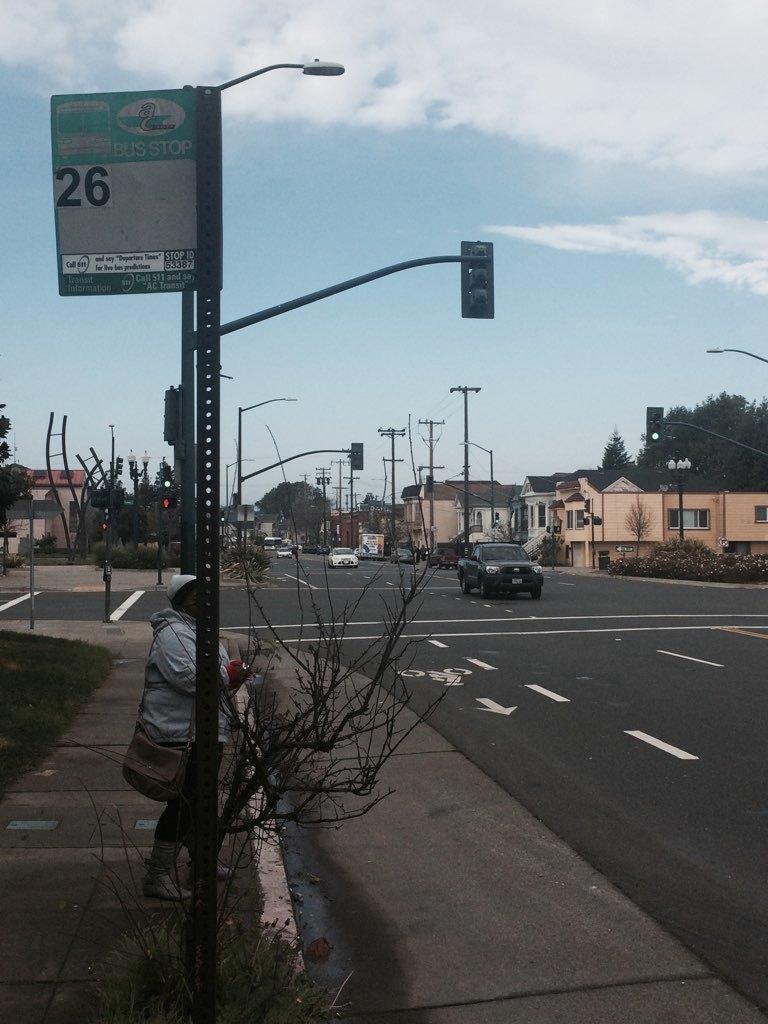Please provide a concise description of this image. At the bottom left of the image there is a footpath with a person is standing. And also there is a pole with posters, street light and traffic signal. At the bottom right corner of the image there is a road with few vehicles on it. And in the background there are electrical poles with wires, trees, houses with roofs, walls and windows. At the top of the image there is a sky with clouds. 